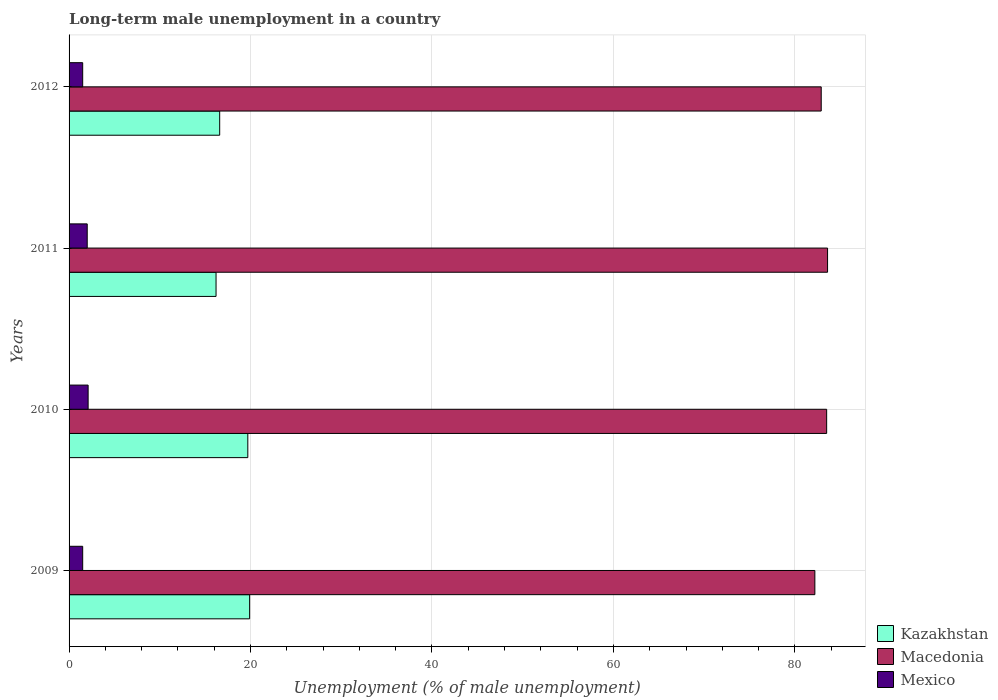How many bars are there on the 4th tick from the bottom?
Give a very brief answer. 3. In how many cases, is the number of bars for a given year not equal to the number of legend labels?
Give a very brief answer. 0. What is the percentage of long-term unemployed male population in Mexico in 2009?
Provide a succinct answer. 1.5. Across all years, what is the maximum percentage of long-term unemployed male population in Macedonia?
Give a very brief answer. 83.6. Across all years, what is the minimum percentage of long-term unemployed male population in Mexico?
Offer a very short reply. 1.5. What is the total percentage of long-term unemployed male population in Mexico in the graph?
Give a very brief answer. 7.1. What is the difference between the percentage of long-term unemployed male population in Kazakhstan in 2010 and that in 2012?
Give a very brief answer. 3.1. What is the difference between the percentage of long-term unemployed male population in Kazakhstan in 2010 and the percentage of long-term unemployed male population in Mexico in 2011?
Make the answer very short. 17.7. What is the average percentage of long-term unemployed male population in Mexico per year?
Your answer should be compact. 1.77. In the year 2009, what is the difference between the percentage of long-term unemployed male population in Macedonia and percentage of long-term unemployed male population in Kazakhstan?
Give a very brief answer. 62.3. What is the ratio of the percentage of long-term unemployed male population in Kazakhstan in 2010 to that in 2012?
Make the answer very short. 1.19. Is the difference between the percentage of long-term unemployed male population in Macedonia in 2010 and 2011 greater than the difference between the percentage of long-term unemployed male population in Kazakhstan in 2010 and 2011?
Offer a very short reply. No. What is the difference between the highest and the second highest percentage of long-term unemployed male population in Kazakhstan?
Make the answer very short. 0.2. What is the difference between the highest and the lowest percentage of long-term unemployed male population in Macedonia?
Make the answer very short. 1.4. In how many years, is the percentage of long-term unemployed male population in Macedonia greater than the average percentage of long-term unemployed male population in Macedonia taken over all years?
Give a very brief answer. 2. Is it the case that in every year, the sum of the percentage of long-term unemployed male population in Mexico and percentage of long-term unemployed male population in Macedonia is greater than the percentage of long-term unemployed male population in Kazakhstan?
Your answer should be very brief. Yes. How many bars are there?
Keep it short and to the point. 12. Are all the bars in the graph horizontal?
Your answer should be compact. Yes. What is the difference between two consecutive major ticks on the X-axis?
Provide a short and direct response. 20. Are the values on the major ticks of X-axis written in scientific E-notation?
Keep it short and to the point. No. What is the title of the graph?
Give a very brief answer. Long-term male unemployment in a country. What is the label or title of the X-axis?
Your answer should be very brief. Unemployment (% of male unemployment). What is the Unemployment (% of male unemployment) of Kazakhstan in 2009?
Your answer should be compact. 19.9. What is the Unemployment (% of male unemployment) in Macedonia in 2009?
Make the answer very short. 82.2. What is the Unemployment (% of male unemployment) of Kazakhstan in 2010?
Your answer should be compact. 19.7. What is the Unemployment (% of male unemployment) in Macedonia in 2010?
Your answer should be compact. 83.5. What is the Unemployment (% of male unemployment) in Mexico in 2010?
Your response must be concise. 2.1. What is the Unemployment (% of male unemployment) of Kazakhstan in 2011?
Keep it short and to the point. 16.2. What is the Unemployment (% of male unemployment) of Macedonia in 2011?
Keep it short and to the point. 83.6. What is the Unemployment (% of male unemployment) in Kazakhstan in 2012?
Your response must be concise. 16.6. What is the Unemployment (% of male unemployment) of Macedonia in 2012?
Make the answer very short. 82.9. What is the Unemployment (% of male unemployment) in Mexico in 2012?
Your answer should be very brief. 1.5. Across all years, what is the maximum Unemployment (% of male unemployment) of Kazakhstan?
Ensure brevity in your answer.  19.9. Across all years, what is the maximum Unemployment (% of male unemployment) in Macedonia?
Make the answer very short. 83.6. Across all years, what is the maximum Unemployment (% of male unemployment) of Mexico?
Your answer should be compact. 2.1. Across all years, what is the minimum Unemployment (% of male unemployment) in Kazakhstan?
Ensure brevity in your answer.  16.2. Across all years, what is the minimum Unemployment (% of male unemployment) in Macedonia?
Offer a very short reply. 82.2. Across all years, what is the minimum Unemployment (% of male unemployment) of Mexico?
Give a very brief answer. 1.5. What is the total Unemployment (% of male unemployment) of Kazakhstan in the graph?
Your answer should be compact. 72.4. What is the total Unemployment (% of male unemployment) of Macedonia in the graph?
Provide a short and direct response. 332.2. What is the total Unemployment (% of male unemployment) of Mexico in the graph?
Ensure brevity in your answer.  7.1. What is the difference between the Unemployment (% of male unemployment) in Macedonia in 2009 and that in 2010?
Offer a terse response. -1.3. What is the difference between the Unemployment (% of male unemployment) of Mexico in 2009 and that in 2010?
Offer a very short reply. -0.6. What is the difference between the Unemployment (% of male unemployment) in Mexico in 2009 and that in 2011?
Provide a short and direct response. -0.5. What is the difference between the Unemployment (% of male unemployment) of Mexico in 2009 and that in 2012?
Your answer should be compact. 0. What is the difference between the Unemployment (% of male unemployment) of Mexico in 2010 and that in 2011?
Provide a succinct answer. 0.1. What is the difference between the Unemployment (% of male unemployment) of Macedonia in 2011 and that in 2012?
Offer a very short reply. 0.7. What is the difference between the Unemployment (% of male unemployment) in Mexico in 2011 and that in 2012?
Keep it short and to the point. 0.5. What is the difference between the Unemployment (% of male unemployment) in Kazakhstan in 2009 and the Unemployment (% of male unemployment) in Macedonia in 2010?
Make the answer very short. -63.6. What is the difference between the Unemployment (% of male unemployment) in Kazakhstan in 2009 and the Unemployment (% of male unemployment) in Mexico in 2010?
Your answer should be very brief. 17.8. What is the difference between the Unemployment (% of male unemployment) in Macedonia in 2009 and the Unemployment (% of male unemployment) in Mexico in 2010?
Keep it short and to the point. 80.1. What is the difference between the Unemployment (% of male unemployment) of Kazakhstan in 2009 and the Unemployment (% of male unemployment) of Macedonia in 2011?
Keep it short and to the point. -63.7. What is the difference between the Unemployment (% of male unemployment) of Macedonia in 2009 and the Unemployment (% of male unemployment) of Mexico in 2011?
Offer a terse response. 80.2. What is the difference between the Unemployment (% of male unemployment) in Kazakhstan in 2009 and the Unemployment (% of male unemployment) in Macedonia in 2012?
Keep it short and to the point. -63. What is the difference between the Unemployment (% of male unemployment) of Macedonia in 2009 and the Unemployment (% of male unemployment) of Mexico in 2012?
Offer a very short reply. 80.7. What is the difference between the Unemployment (% of male unemployment) of Kazakhstan in 2010 and the Unemployment (% of male unemployment) of Macedonia in 2011?
Give a very brief answer. -63.9. What is the difference between the Unemployment (% of male unemployment) of Macedonia in 2010 and the Unemployment (% of male unemployment) of Mexico in 2011?
Keep it short and to the point. 81.5. What is the difference between the Unemployment (% of male unemployment) in Kazakhstan in 2010 and the Unemployment (% of male unemployment) in Macedonia in 2012?
Keep it short and to the point. -63.2. What is the difference between the Unemployment (% of male unemployment) of Kazakhstan in 2010 and the Unemployment (% of male unemployment) of Mexico in 2012?
Offer a very short reply. 18.2. What is the difference between the Unemployment (% of male unemployment) in Kazakhstan in 2011 and the Unemployment (% of male unemployment) in Macedonia in 2012?
Keep it short and to the point. -66.7. What is the difference between the Unemployment (% of male unemployment) of Macedonia in 2011 and the Unemployment (% of male unemployment) of Mexico in 2012?
Offer a very short reply. 82.1. What is the average Unemployment (% of male unemployment) in Macedonia per year?
Ensure brevity in your answer.  83.05. What is the average Unemployment (% of male unemployment) of Mexico per year?
Make the answer very short. 1.77. In the year 2009, what is the difference between the Unemployment (% of male unemployment) of Kazakhstan and Unemployment (% of male unemployment) of Macedonia?
Your answer should be compact. -62.3. In the year 2009, what is the difference between the Unemployment (% of male unemployment) in Kazakhstan and Unemployment (% of male unemployment) in Mexico?
Offer a terse response. 18.4. In the year 2009, what is the difference between the Unemployment (% of male unemployment) in Macedonia and Unemployment (% of male unemployment) in Mexico?
Keep it short and to the point. 80.7. In the year 2010, what is the difference between the Unemployment (% of male unemployment) of Kazakhstan and Unemployment (% of male unemployment) of Macedonia?
Provide a short and direct response. -63.8. In the year 2010, what is the difference between the Unemployment (% of male unemployment) of Kazakhstan and Unemployment (% of male unemployment) of Mexico?
Make the answer very short. 17.6. In the year 2010, what is the difference between the Unemployment (% of male unemployment) in Macedonia and Unemployment (% of male unemployment) in Mexico?
Offer a very short reply. 81.4. In the year 2011, what is the difference between the Unemployment (% of male unemployment) in Kazakhstan and Unemployment (% of male unemployment) in Macedonia?
Keep it short and to the point. -67.4. In the year 2011, what is the difference between the Unemployment (% of male unemployment) in Macedonia and Unemployment (% of male unemployment) in Mexico?
Your answer should be compact. 81.6. In the year 2012, what is the difference between the Unemployment (% of male unemployment) in Kazakhstan and Unemployment (% of male unemployment) in Macedonia?
Keep it short and to the point. -66.3. In the year 2012, what is the difference between the Unemployment (% of male unemployment) in Macedonia and Unemployment (% of male unemployment) in Mexico?
Offer a very short reply. 81.4. What is the ratio of the Unemployment (% of male unemployment) in Kazakhstan in 2009 to that in 2010?
Offer a very short reply. 1.01. What is the ratio of the Unemployment (% of male unemployment) of Macedonia in 2009 to that in 2010?
Ensure brevity in your answer.  0.98. What is the ratio of the Unemployment (% of male unemployment) of Kazakhstan in 2009 to that in 2011?
Ensure brevity in your answer.  1.23. What is the ratio of the Unemployment (% of male unemployment) of Macedonia in 2009 to that in 2011?
Your response must be concise. 0.98. What is the ratio of the Unemployment (% of male unemployment) in Kazakhstan in 2009 to that in 2012?
Offer a very short reply. 1.2. What is the ratio of the Unemployment (% of male unemployment) in Mexico in 2009 to that in 2012?
Your answer should be very brief. 1. What is the ratio of the Unemployment (% of male unemployment) in Kazakhstan in 2010 to that in 2011?
Ensure brevity in your answer.  1.22. What is the ratio of the Unemployment (% of male unemployment) in Mexico in 2010 to that in 2011?
Your answer should be very brief. 1.05. What is the ratio of the Unemployment (% of male unemployment) in Kazakhstan in 2010 to that in 2012?
Your answer should be very brief. 1.19. What is the ratio of the Unemployment (% of male unemployment) of Macedonia in 2010 to that in 2012?
Your answer should be compact. 1.01. What is the ratio of the Unemployment (% of male unemployment) in Mexico in 2010 to that in 2012?
Provide a short and direct response. 1.4. What is the ratio of the Unemployment (% of male unemployment) of Kazakhstan in 2011 to that in 2012?
Give a very brief answer. 0.98. What is the ratio of the Unemployment (% of male unemployment) in Macedonia in 2011 to that in 2012?
Make the answer very short. 1.01. What is the ratio of the Unemployment (% of male unemployment) in Mexico in 2011 to that in 2012?
Give a very brief answer. 1.33. What is the difference between the highest and the lowest Unemployment (% of male unemployment) of Macedonia?
Make the answer very short. 1.4. What is the difference between the highest and the lowest Unemployment (% of male unemployment) in Mexico?
Your response must be concise. 0.6. 